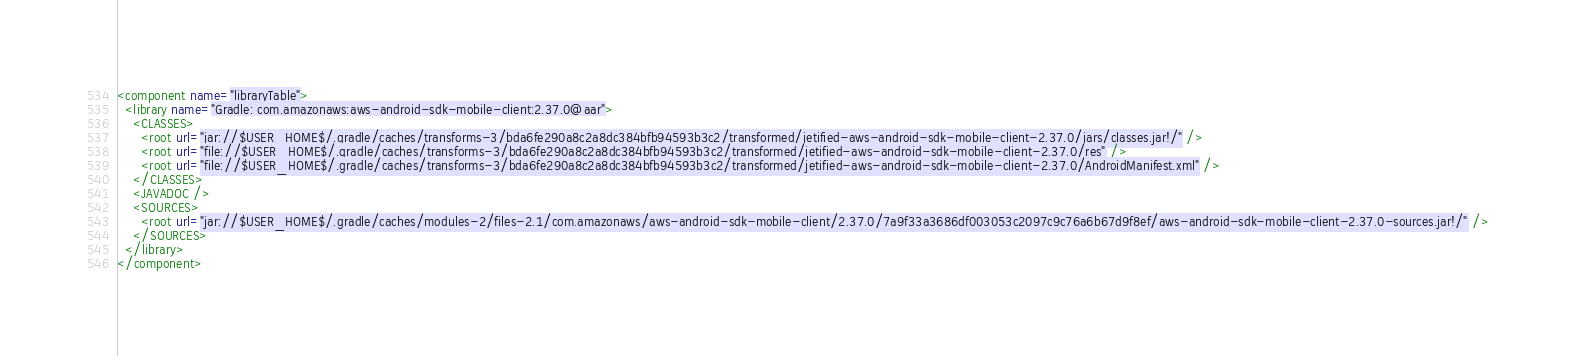<code> <loc_0><loc_0><loc_500><loc_500><_XML_><component name="libraryTable">
  <library name="Gradle: com.amazonaws:aws-android-sdk-mobile-client:2.37.0@aar">
    <CLASSES>
      <root url="jar://$USER_HOME$/.gradle/caches/transforms-3/bda6fe290a8c2a8dc384bfb94593b3c2/transformed/jetified-aws-android-sdk-mobile-client-2.37.0/jars/classes.jar!/" />
      <root url="file://$USER_HOME$/.gradle/caches/transforms-3/bda6fe290a8c2a8dc384bfb94593b3c2/transformed/jetified-aws-android-sdk-mobile-client-2.37.0/res" />
      <root url="file://$USER_HOME$/.gradle/caches/transforms-3/bda6fe290a8c2a8dc384bfb94593b3c2/transformed/jetified-aws-android-sdk-mobile-client-2.37.0/AndroidManifest.xml" />
    </CLASSES>
    <JAVADOC />
    <SOURCES>
      <root url="jar://$USER_HOME$/.gradle/caches/modules-2/files-2.1/com.amazonaws/aws-android-sdk-mobile-client/2.37.0/7a9f33a3686df003053c2097c9c76a6b67d9f8ef/aws-android-sdk-mobile-client-2.37.0-sources.jar!/" />
    </SOURCES>
  </library>
</component></code> 